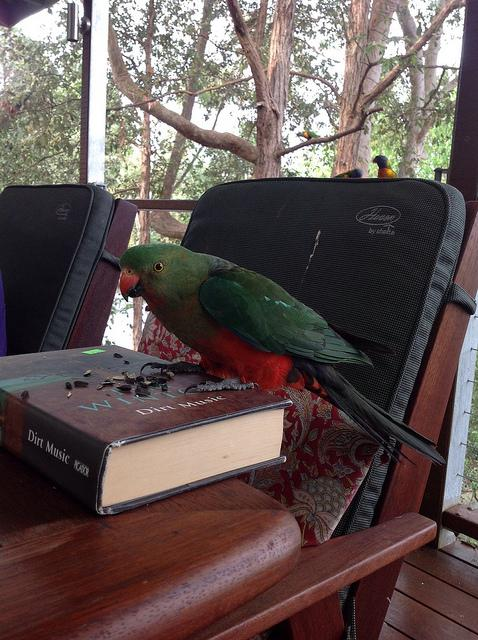What makes up the bulk of this bird's diet? seeds 